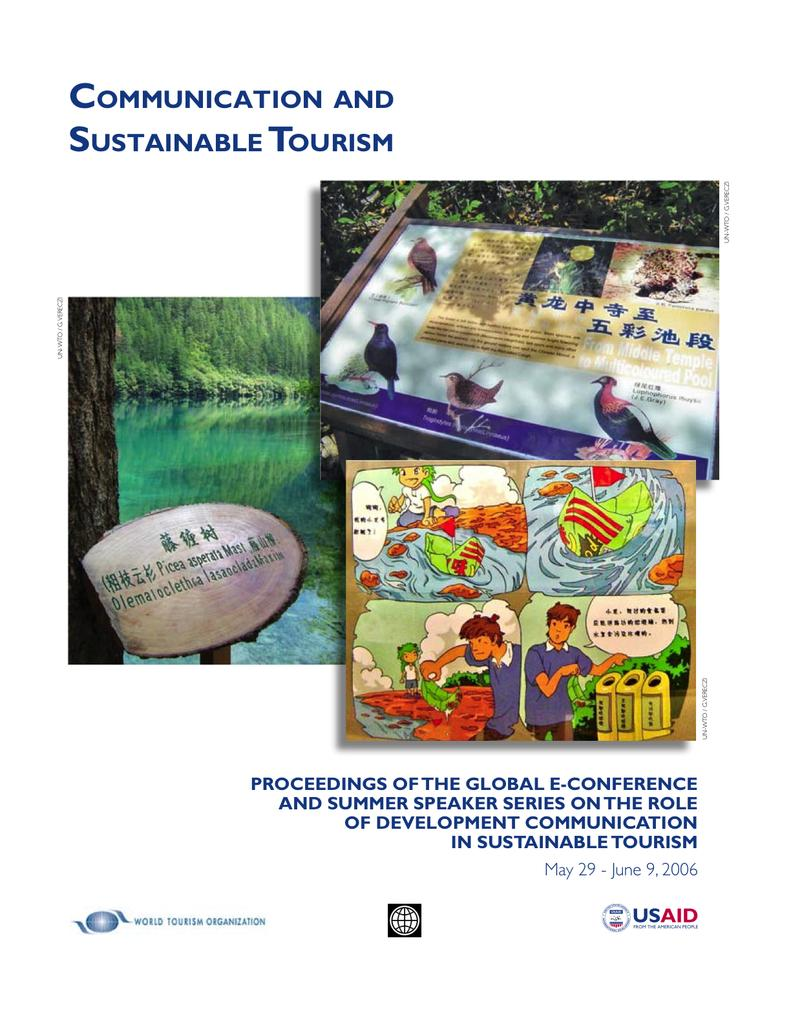What is featured on the posters in the image? The posters contain text and images. Can you describe the content of the posters? The posters contain text and images, but the specific content cannot be determined from the provided facts. Is there any visible text in the image? Yes, there is text visible in the image. What type of waste can be seen being smashed by a trick in the image? There is no waste, smashing, or trick present in the image. 